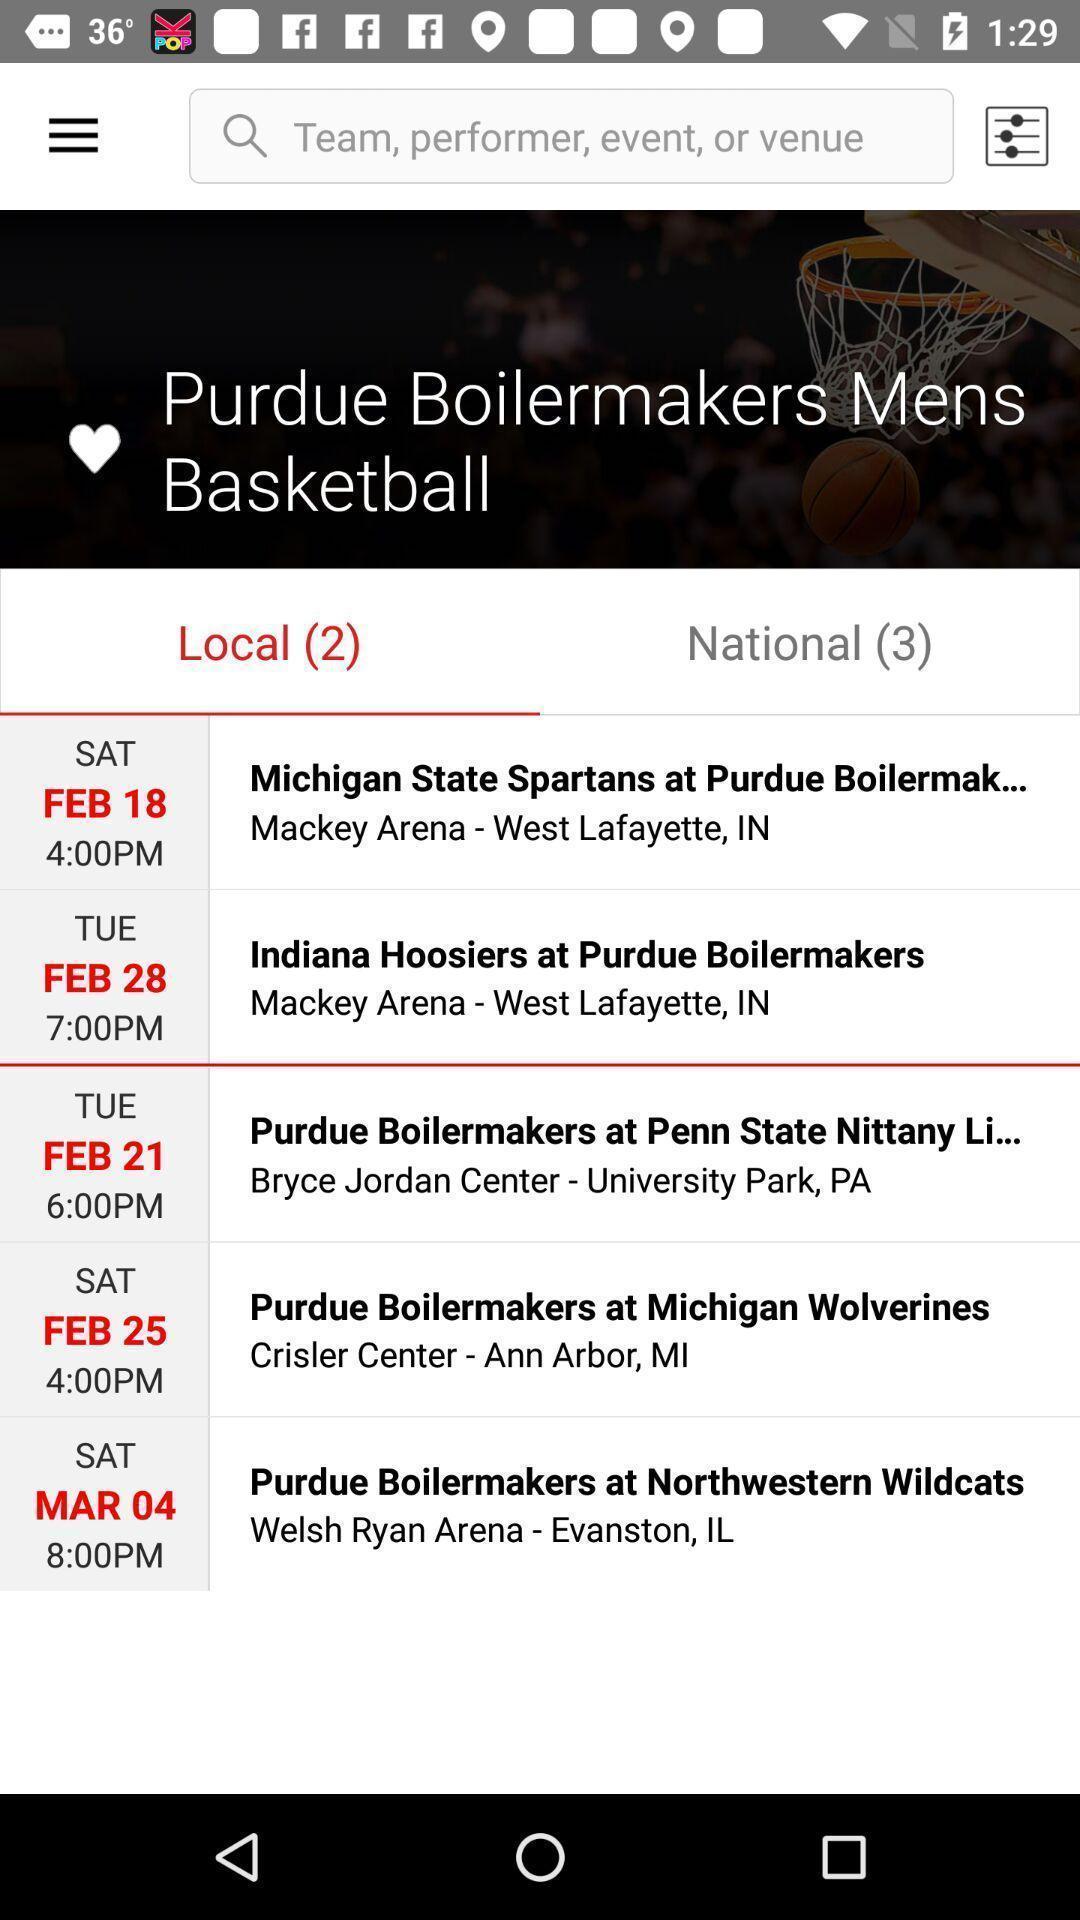Describe this image in words. Search bar with other event details. 